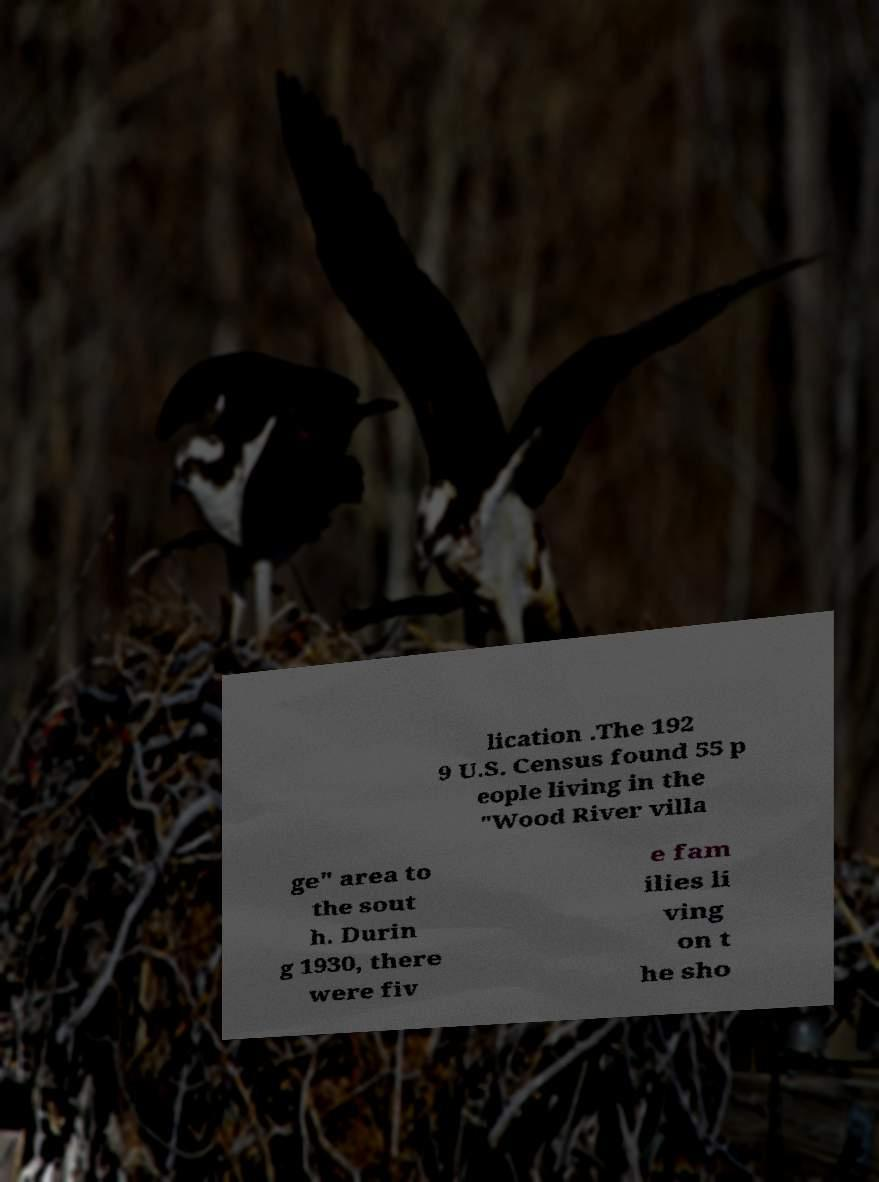Can you accurately transcribe the text from the provided image for me? lication .The 192 9 U.S. Census found 55 p eople living in the "Wood River villa ge" area to the sout h. Durin g 1930, there were fiv e fam ilies li ving on t he sho 